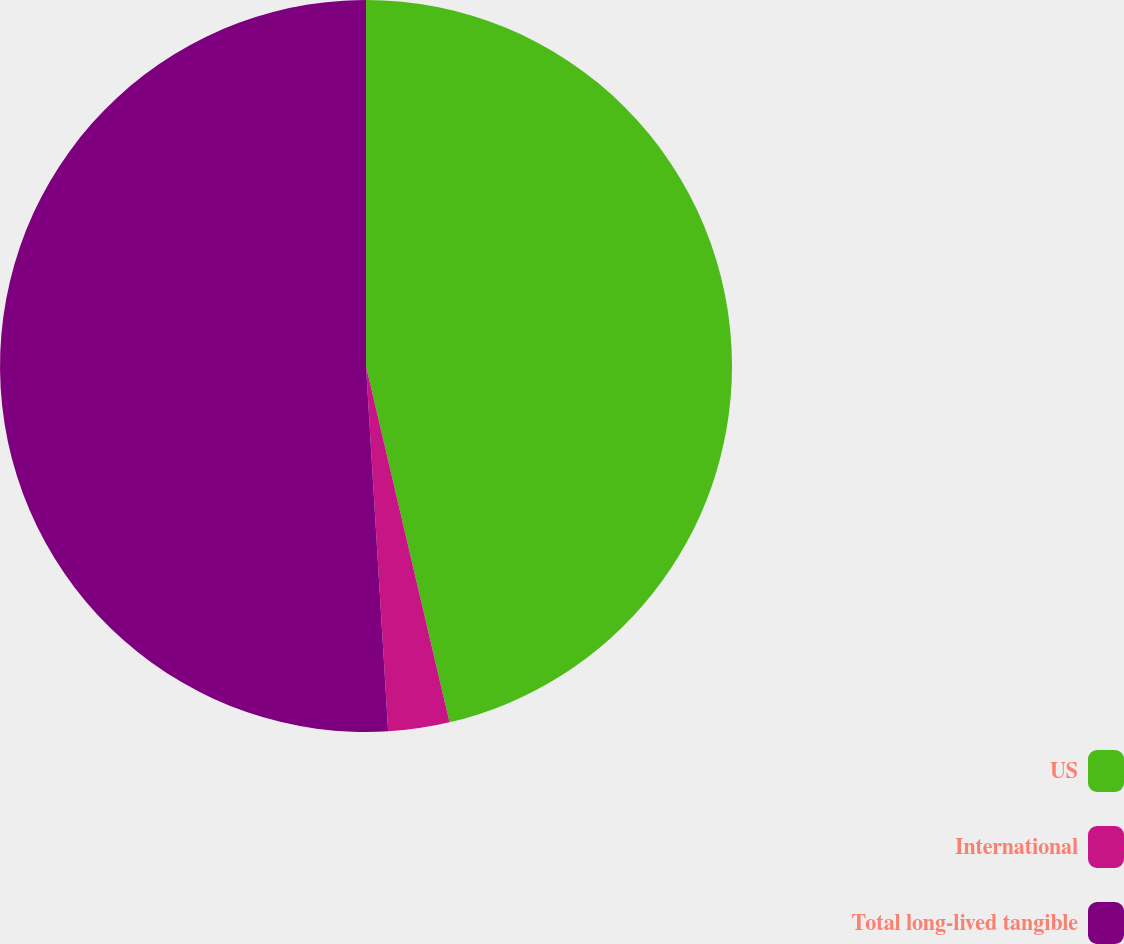Convert chart to OTSL. <chart><loc_0><loc_0><loc_500><loc_500><pie_chart><fcel>US<fcel>International<fcel>Total long-lived tangible<nl><fcel>46.34%<fcel>2.7%<fcel>50.97%<nl></chart> 